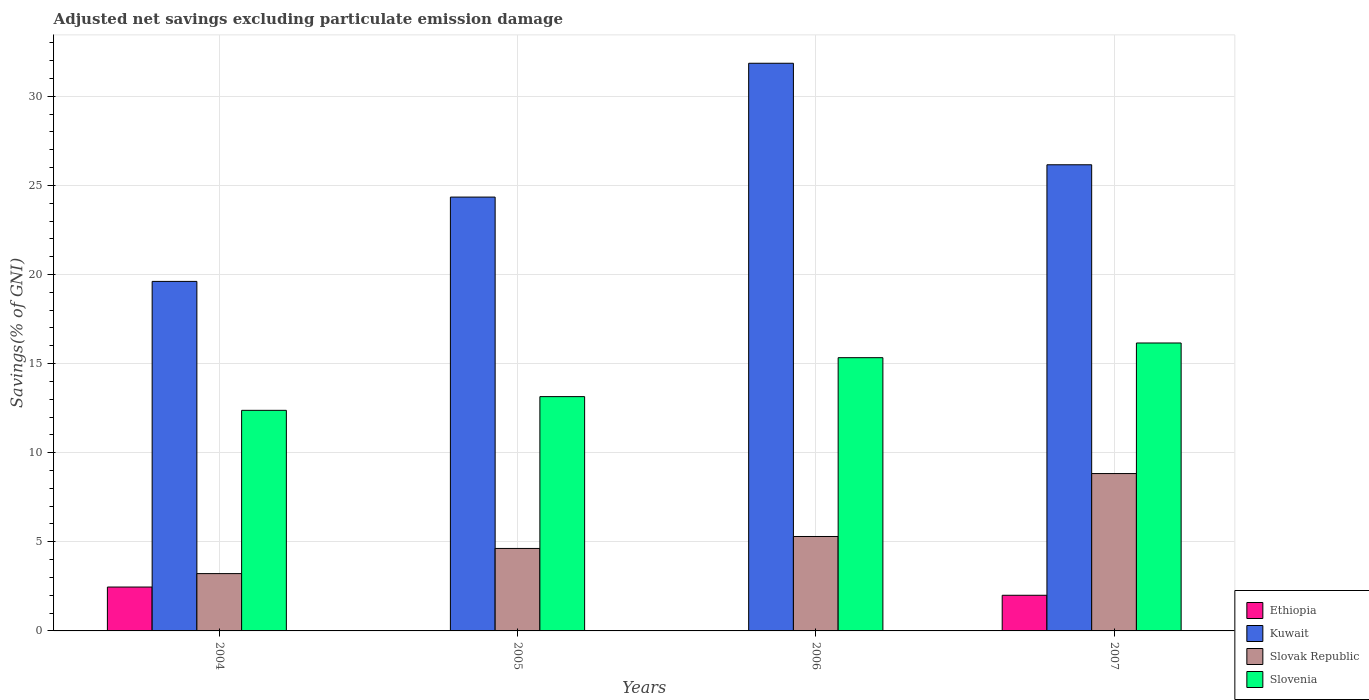How many groups of bars are there?
Your answer should be very brief. 4. Are the number of bars on each tick of the X-axis equal?
Keep it short and to the point. No. How many bars are there on the 1st tick from the left?
Keep it short and to the point. 4. How many bars are there on the 3rd tick from the right?
Your answer should be compact. 3. In how many cases, is the number of bars for a given year not equal to the number of legend labels?
Your response must be concise. 2. What is the adjusted net savings in Kuwait in 2006?
Give a very brief answer. 31.85. Across all years, what is the maximum adjusted net savings in Ethiopia?
Your response must be concise. 2.46. Across all years, what is the minimum adjusted net savings in Kuwait?
Provide a succinct answer. 19.61. In which year was the adjusted net savings in Slovak Republic maximum?
Offer a very short reply. 2007. What is the total adjusted net savings in Ethiopia in the graph?
Your answer should be compact. 4.46. What is the difference between the adjusted net savings in Kuwait in 2005 and that in 2006?
Offer a terse response. -7.51. What is the difference between the adjusted net savings in Kuwait in 2007 and the adjusted net savings in Ethiopia in 2005?
Offer a very short reply. 26.16. What is the average adjusted net savings in Ethiopia per year?
Provide a succinct answer. 1.12. In the year 2004, what is the difference between the adjusted net savings in Slovenia and adjusted net savings in Ethiopia?
Your response must be concise. 9.92. In how many years, is the adjusted net savings in Slovak Republic greater than 15 %?
Ensure brevity in your answer.  0. What is the ratio of the adjusted net savings in Kuwait in 2005 to that in 2006?
Offer a very short reply. 0.76. Is the adjusted net savings in Kuwait in 2005 less than that in 2006?
Provide a short and direct response. Yes. What is the difference between the highest and the second highest adjusted net savings in Kuwait?
Your answer should be compact. 5.7. What is the difference between the highest and the lowest adjusted net savings in Ethiopia?
Offer a terse response. 2.46. Is it the case that in every year, the sum of the adjusted net savings in Slovak Republic and adjusted net savings in Slovenia is greater than the sum of adjusted net savings in Ethiopia and adjusted net savings in Kuwait?
Provide a succinct answer. Yes. What is the difference between two consecutive major ticks on the Y-axis?
Offer a terse response. 5. Are the values on the major ticks of Y-axis written in scientific E-notation?
Your answer should be very brief. No. Does the graph contain any zero values?
Ensure brevity in your answer.  Yes. Does the graph contain grids?
Offer a very short reply. Yes. What is the title of the graph?
Your answer should be very brief. Adjusted net savings excluding particulate emission damage. Does "Nicaragua" appear as one of the legend labels in the graph?
Provide a short and direct response. No. What is the label or title of the X-axis?
Your answer should be very brief. Years. What is the label or title of the Y-axis?
Ensure brevity in your answer.  Savings(% of GNI). What is the Savings(% of GNI) in Ethiopia in 2004?
Offer a terse response. 2.46. What is the Savings(% of GNI) in Kuwait in 2004?
Your answer should be very brief. 19.61. What is the Savings(% of GNI) in Slovak Republic in 2004?
Provide a short and direct response. 3.22. What is the Savings(% of GNI) of Slovenia in 2004?
Your answer should be very brief. 12.38. What is the Savings(% of GNI) in Ethiopia in 2005?
Your answer should be compact. 0. What is the Savings(% of GNI) of Kuwait in 2005?
Your answer should be compact. 24.35. What is the Savings(% of GNI) of Slovak Republic in 2005?
Ensure brevity in your answer.  4.63. What is the Savings(% of GNI) of Slovenia in 2005?
Your answer should be very brief. 13.15. What is the Savings(% of GNI) of Kuwait in 2006?
Give a very brief answer. 31.85. What is the Savings(% of GNI) in Slovak Republic in 2006?
Your answer should be compact. 5.3. What is the Savings(% of GNI) of Slovenia in 2006?
Provide a short and direct response. 15.33. What is the Savings(% of GNI) of Ethiopia in 2007?
Offer a terse response. 2. What is the Savings(% of GNI) of Kuwait in 2007?
Ensure brevity in your answer.  26.16. What is the Savings(% of GNI) of Slovak Republic in 2007?
Offer a terse response. 8.83. What is the Savings(% of GNI) of Slovenia in 2007?
Your answer should be compact. 16.16. Across all years, what is the maximum Savings(% of GNI) of Ethiopia?
Your answer should be very brief. 2.46. Across all years, what is the maximum Savings(% of GNI) in Kuwait?
Keep it short and to the point. 31.85. Across all years, what is the maximum Savings(% of GNI) of Slovak Republic?
Provide a succinct answer. 8.83. Across all years, what is the maximum Savings(% of GNI) of Slovenia?
Make the answer very short. 16.16. Across all years, what is the minimum Savings(% of GNI) in Ethiopia?
Make the answer very short. 0. Across all years, what is the minimum Savings(% of GNI) of Kuwait?
Keep it short and to the point. 19.61. Across all years, what is the minimum Savings(% of GNI) in Slovak Republic?
Offer a terse response. 3.22. Across all years, what is the minimum Savings(% of GNI) in Slovenia?
Your response must be concise. 12.38. What is the total Savings(% of GNI) in Ethiopia in the graph?
Provide a succinct answer. 4.46. What is the total Savings(% of GNI) of Kuwait in the graph?
Keep it short and to the point. 101.97. What is the total Savings(% of GNI) in Slovak Republic in the graph?
Your response must be concise. 21.97. What is the total Savings(% of GNI) of Slovenia in the graph?
Offer a terse response. 57.02. What is the difference between the Savings(% of GNI) of Kuwait in 2004 and that in 2005?
Offer a very short reply. -4.73. What is the difference between the Savings(% of GNI) of Slovak Republic in 2004 and that in 2005?
Provide a succinct answer. -1.41. What is the difference between the Savings(% of GNI) of Slovenia in 2004 and that in 2005?
Keep it short and to the point. -0.77. What is the difference between the Savings(% of GNI) in Kuwait in 2004 and that in 2006?
Your answer should be compact. -12.24. What is the difference between the Savings(% of GNI) of Slovak Republic in 2004 and that in 2006?
Your response must be concise. -2.08. What is the difference between the Savings(% of GNI) of Slovenia in 2004 and that in 2006?
Provide a succinct answer. -2.95. What is the difference between the Savings(% of GNI) of Ethiopia in 2004 and that in 2007?
Ensure brevity in your answer.  0.46. What is the difference between the Savings(% of GNI) of Kuwait in 2004 and that in 2007?
Offer a very short reply. -6.55. What is the difference between the Savings(% of GNI) of Slovak Republic in 2004 and that in 2007?
Offer a terse response. -5.61. What is the difference between the Savings(% of GNI) of Slovenia in 2004 and that in 2007?
Your answer should be compact. -3.78. What is the difference between the Savings(% of GNI) in Kuwait in 2005 and that in 2006?
Keep it short and to the point. -7.51. What is the difference between the Savings(% of GNI) in Slovak Republic in 2005 and that in 2006?
Provide a short and direct response. -0.67. What is the difference between the Savings(% of GNI) in Slovenia in 2005 and that in 2006?
Ensure brevity in your answer.  -2.19. What is the difference between the Savings(% of GNI) of Kuwait in 2005 and that in 2007?
Provide a succinct answer. -1.81. What is the difference between the Savings(% of GNI) of Slovak Republic in 2005 and that in 2007?
Your answer should be compact. -4.2. What is the difference between the Savings(% of GNI) in Slovenia in 2005 and that in 2007?
Your answer should be very brief. -3.01. What is the difference between the Savings(% of GNI) of Kuwait in 2006 and that in 2007?
Keep it short and to the point. 5.7. What is the difference between the Savings(% of GNI) of Slovak Republic in 2006 and that in 2007?
Your answer should be very brief. -3.53. What is the difference between the Savings(% of GNI) of Slovenia in 2006 and that in 2007?
Offer a terse response. -0.82. What is the difference between the Savings(% of GNI) of Ethiopia in 2004 and the Savings(% of GNI) of Kuwait in 2005?
Offer a terse response. -21.88. What is the difference between the Savings(% of GNI) in Ethiopia in 2004 and the Savings(% of GNI) in Slovak Republic in 2005?
Your answer should be very brief. -2.17. What is the difference between the Savings(% of GNI) of Ethiopia in 2004 and the Savings(% of GNI) of Slovenia in 2005?
Provide a short and direct response. -10.69. What is the difference between the Savings(% of GNI) in Kuwait in 2004 and the Savings(% of GNI) in Slovak Republic in 2005?
Provide a succinct answer. 14.99. What is the difference between the Savings(% of GNI) in Kuwait in 2004 and the Savings(% of GNI) in Slovenia in 2005?
Your answer should be compact. 6.47. What is the difference between the Savings(% of GNI) in Slovak Republic in 2004 and the Savings(% of GNI) in Slovenia in 2005?
Offer a very short reply. -9.93. What is the difference between the Savings(% of GNI) of Ethiopia in 2004 and the Savings(% of GNI) of Kuwait in 2006?
Your answer should be compact. -29.39. What is the difference between the Savings(% of GNI) in Ethiopia in 2004 and the Savings(% of GNI) in Slovak Republic in 2006?
Your answer should be compact. -2.84. What is the difference between the Savings(% of GNI) of Ethiopia in 2004 and the Savings(% of GNI) of Slovenia in 2006?
Your answer should be compact. -12.87. What is the difference between the Savings(% of GNI) in Kuwait in 2004 and the Savings(% of GNI) in Slovak Republic in 2006?
Keep it short and to the point. 14.31. What is the difference between the Savings(% of GNI) of Kuwait in 2004 and the Savings(% of GNI) of Slovenia in 2006?
Keep it short and to the point. 4.28. What is the difference between the Savings(% of GNI) of Slovak Republic in 2004 and the Savings(% of GNI) of Slovenia in 2006?
Provide a short and direct response. -12.12. What is the difference between the Savings(% of GNI) in Ethiopia in 2004 and the Savings(% of GNI) in Kuwait in 2007?
Make the answer very short. -23.7. What is the difference between the Savings(% of GNI) in Ethiopia in 2004 and the Savings(% of GNI) in Slovak Republic in 2007?
Your answer should be very brief. -6.37. What is the difference between the Savings(% of GNI) of Ethiopia in 2004 and the Savings(% of GNI) of Slovenia in 2007?
Your answer should be very brief. -13.7. What is the difference between the Savings(% of GNI) in Kuwait in 2004 and the Savings(% of GNI) in Slovak Republic in 2007?
Make the answer very short. 10.78. What is the difference between the Savings(% of GNI) in Kuwait in 2004 and the Savings(% of GNI) in Slovenia in 2007?
Offer a very short reply. 3.46. What is the difference between the Savings(% of GNI) in Slovak Republic in 2004 and the Savings(% of GNI) in Slovenia in 2007?
Provide a succinct answer. -12.94. What is the difference between the Savings(% of GNI) in Kuwait in 2005 and the Savings(% of GNI) in Slovak Republic in 2006?
Ensure brevity in your answer.  19.05. What is the difference between the Savings(% of GNI) in Kuwait in 2005 and the Savings(% of GNI) in Slovenia in 2006?
Make the answer very short. 9.01. What is the difference between the Savings(% of GNI) in Slovak Republic in 2005 and the Savings(% of GNI) in Slovenia in 2006?
Give a very brief answer. -10.71. What is the difference between the Savings(% of GNI) of Kuwait in 2005 and the Savings(% of GNI) of Slovak Republic in 2007?
Ensure brevity in your answer.  15.51. What is the difference between the Savings(% of GNI) in Kuwait in 2005 and the Savings(% of GNI) in Slovenia in 2007?
Ensure brevity in your answer.  8.19. What is the difference between the Savings(% of GNI) in Slovak Republic in 2005 and the Savings(% of GNI) in Slovenia in 2007?
Offer a very short reply. -11.53. What is the difference between the Savings(% of GNI) of Kuwait in 2006 and the Savings(% of GNI) of Slovak Republic in 2007?
Your answer should be compact. 23.02. What is the difference between the Savings(% of GNI) of Kuwait in 2006 and the Savings(% of GNI) of Slovenia in 2007?
Offer a very short reply. 15.7. What is the difference between the Savings(% of GNI) of Slovak Republic in 2006 and the Savings(% of GNI) of Slovenia in 2007?
Your response must be concise. -10.86. What is the average Savings(% of GNI) of Ethiopia per year?
Offer a terse response. 1.12. What is the average Savings(% of GNI) of Kuwait per year?
Provide a short and direct response. 25.49. What is the average Savings(% of GNI) of Slovak Republic per year?
Offer a terse response. 5.49. What is the average Savings(% of GNI) of Slovenia per year?
Keep it short and to the point. 14.25. In the year 2004, what is the difference between the Savings(% of GNI) in Ethiopia and Savings(% of GNI) in Kuwait?
Your response must be concise. -17.15. In the year 2004, what is the difference between the Savings(% of GNI) of Ethiopia and Savings(% of GNI) of Slovak Republic?
Your response must be concise. -0.75. In the year 2004, what is the difference between the Savings(% of GNI) in Ethiopia and Savings(% of GNI) in Slovenia?
Provide a short and direct response. -9.92. In the year 2004, what is the difference between the Savings(% of GNI) of Kuwait and Savings(% of GNI) of Slovak Republic?
Give a very brief answer. 16.4. In the year 2004, what is the difference between the Savings(% of GNI) of Kuwait and Savings(% of GNI) of Slovenia?
Offer a terse response. 7.23. In the year 2004, what is the difference between the Savings(% of GNI) of Slovak Republic and Savings(% of GNI) of Slovenia?
Provide a succinct answer. -9.16. In the year 2005, what is the difference between the Savings(% of GNI) of Kuwait and Savings(% of GNI) of Slovak Republic?
Your response must be concise. 19.72. In the year 2005, what is the difference between the Savings(% of GNI) in Kuwait and Savings(% of GNI) in Slovenia?
Give a very brief answer. 11.2. In the year 2005, what is the difference between the Savings(% of GNI) in Slovak Republic and Savings(% of GNI) in Slovenia?
Offer a terse response. -8.52. In the year 2006, what is the difference between the Savings(% of GNI) in Kuwait and Savings(% of GNI) in Slovak Republic?
Your answer should be very brief. 26.56. In the year 2006, what is the difference between the Savings(% of GNI) in Kuwait and Savings(% of GNI) in Slovenia?
Your answer should be compact. 16.52. In the year 2006, what is the difference between the Savings(% of GNI) in Slovak Republic and Savings(% of GNI) in Slovenia?
Your answer should be compact. -10.03. In the year 2007, what is the difference between the Savings(% of GNI) in Ethiopia and Savings(% of GNI) in Kuwait?
Keep it short and to the point. -24.16. In the year 2007, what is the difference between the Savings(% of GNI) of Ethiopia and Savings(% of GNI) of Slovak Republic?
Your answer should be very brief. -6.83. In the year 2007, what is the difference between the Savings(% of GNI) in Ethiopia and Savings(% of GNI) in Slovenia?
Your response must be concise. -14.16. In the year 2007, what is the difference between the Savings(% of GNI) in Kuwait and Savings(% of GNI) in Slovak Republic?
Provide a short and direct response. 17.33. In the year 2007, what is the difference between the Savings(% of GNI) in Kuwait and Savings(% of GNI) in Slovenia?
Offer a very short reply. 10. In the year 2007, what is the difference between the Savings(% of GNI) of Slovak Republic and Savings(% of GNI) of Slovenia?
Keep it short and to the point. -7.33. What is the ratio of the Savings(% of GNI) in Kuwait in 2004 to that in 2005?
Your answer should be very brief. 0.81. What is the ratio of the Savings(% of GNI) of Slovak Republic in 2004 to that in 2005?
Offer a very short reply. 0.69. What is the ratio of the Savings(% of GNI) in Slovenia in 2004 to that in 2005?
Ensure brevity in your answer.  0.94. What is the ratio of the Savings(% of GNI) of Kuwait in 2004 to that in 2006?
Keep it short and to the point. 0.62. What is the ratio of the Savings(% of GNI) of Slovak Republic in 2004 to that in 2006?
Your answer should be very brief. 0.61. What is the ratio of the Savings(% of GNI) of Slovenia in 2004 to that in 2006?
Your response must be concise. 0.81. What is the ratio of the Savings(% of GNI) in Ethiopia in 2004 to that in 2007?
Your answer should be very brief. 1.23. What is the ratio of the Savings(% of GNI) of Kuwait in 2004 to that in 2007?
Give a very brief answer. 0.75. What is the ratio of the Savings(% of GNI) in Slovak Republic in 2004 to that in 2007?
Your response must be concise. 0.36. What is the ratio of the Savings(% of GNI) of Slovenia in 2004 to that in 2007?
Give a very brief answer. 0.77. What is the ratio of the Savings(% of GNI) of Kuwait in 2005 to that in 2006?
Make the answer very short. 0.76. What is the ratio of the Savings(% of GNI) of Slovak Republic in 2005 to that in 2006?
Provide a short and direct response. 0.87. What is the ratio of the Savings(% of GNI) of Slovenia in 2005 to that in 2006?
Your answer should be very brief. 0.86. What is the ratio of the Savings(% of GNI) in Kuwait in 2005 to that in 2007?
Keep it short and to the point. 0.93. What is the ratio of the Savings(% of GNI) in Slovak Republic in 2005 to that in 2007?
Give a very brief answer. 0.52. What is the ratio of the Savings(% of GNI) of Slovenia in 2005 to that in 2007?
Your answer should be very brief. 0.81. What is the ratio of the Savings(% of GNI) of Kuwait in 2006 to that in 2007?
Ensure brevity in your answer.  1.22. What is the ratio of the Savings(% of GNI) of Slovak Republic in 2006 to that in 2007?
Your answer should be compact. 0.6. What is the ratio of the Savings(% of GNI) of Slovenia in 2006 to that in 2007?
Give a very brief answer. 0.95. What is the difference between the highest and the second highest Savings(% of GNI) in Kuwait?
Your answer should be very brief. 5.7. What is the difference between the highest and the second highest Savings(% of GNI) in Slovak Republic?
Provide a short and direct response. 3.53. What is the difference between the highest and the second highest Savings(% of GNI) of Slovenia?
Your answer should be very brief. 0.82. What is the difference between the highest and the lowest Savings(% of GNI) of Ethiopia?
Give a very brief answer. 2.46. What is the difference between the highest and the lowest Savings(% of GNI) in Kuwait?
Make the answer very short. 12.24. What is the difference between the highest and the lowest Savings(% of GNI) of Slovak Republic?
Your answer should be very brief. 5.61. What is the difference between the highest and the lowest Savings(% of GNI) of Slovenia?
Keep it short and to the point. 3.78. 